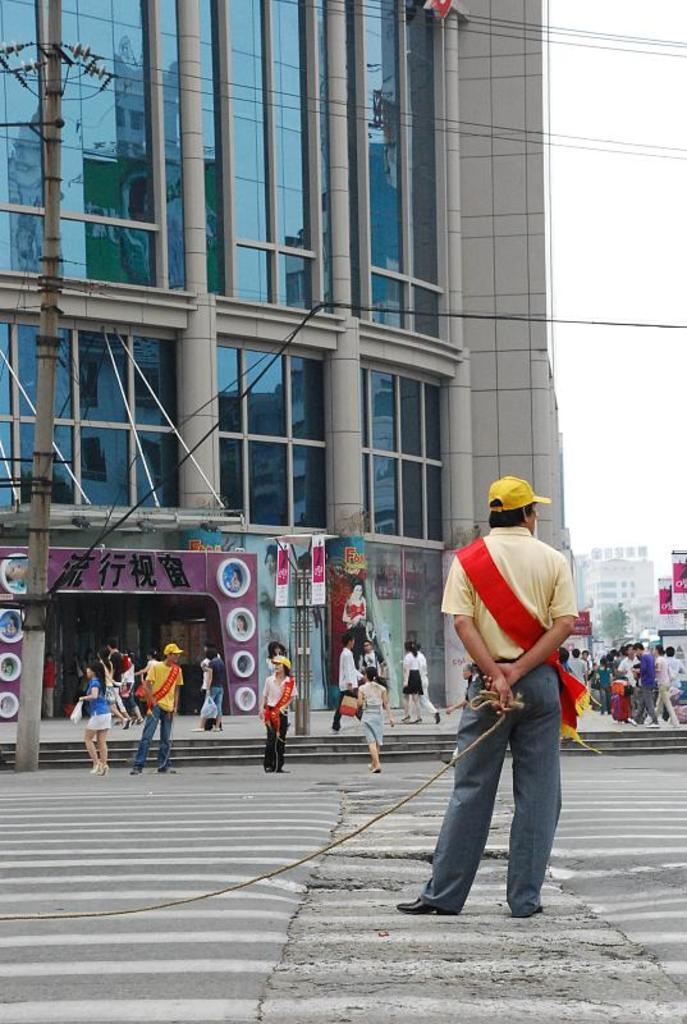How would you summarize this image in a sentence or two? In this image we can see people standing on the road and some are walking on the road. In the background we can see stores, advertisement boards to the poles, electric poles, electric cables, buildings and sky. 